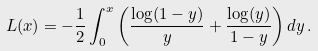Convert formula to latex. <formula><loc_0><loc_0><loc_500><loc_500>L ( x ) = - \frac { 1 } { 2 } \int _ { 0 } ^ { x } \left ( \frac { \log ( 1 - y ) } { y } + \frac { \log ( y ) } { 1 - y } \right ) d y \, .</formula> 